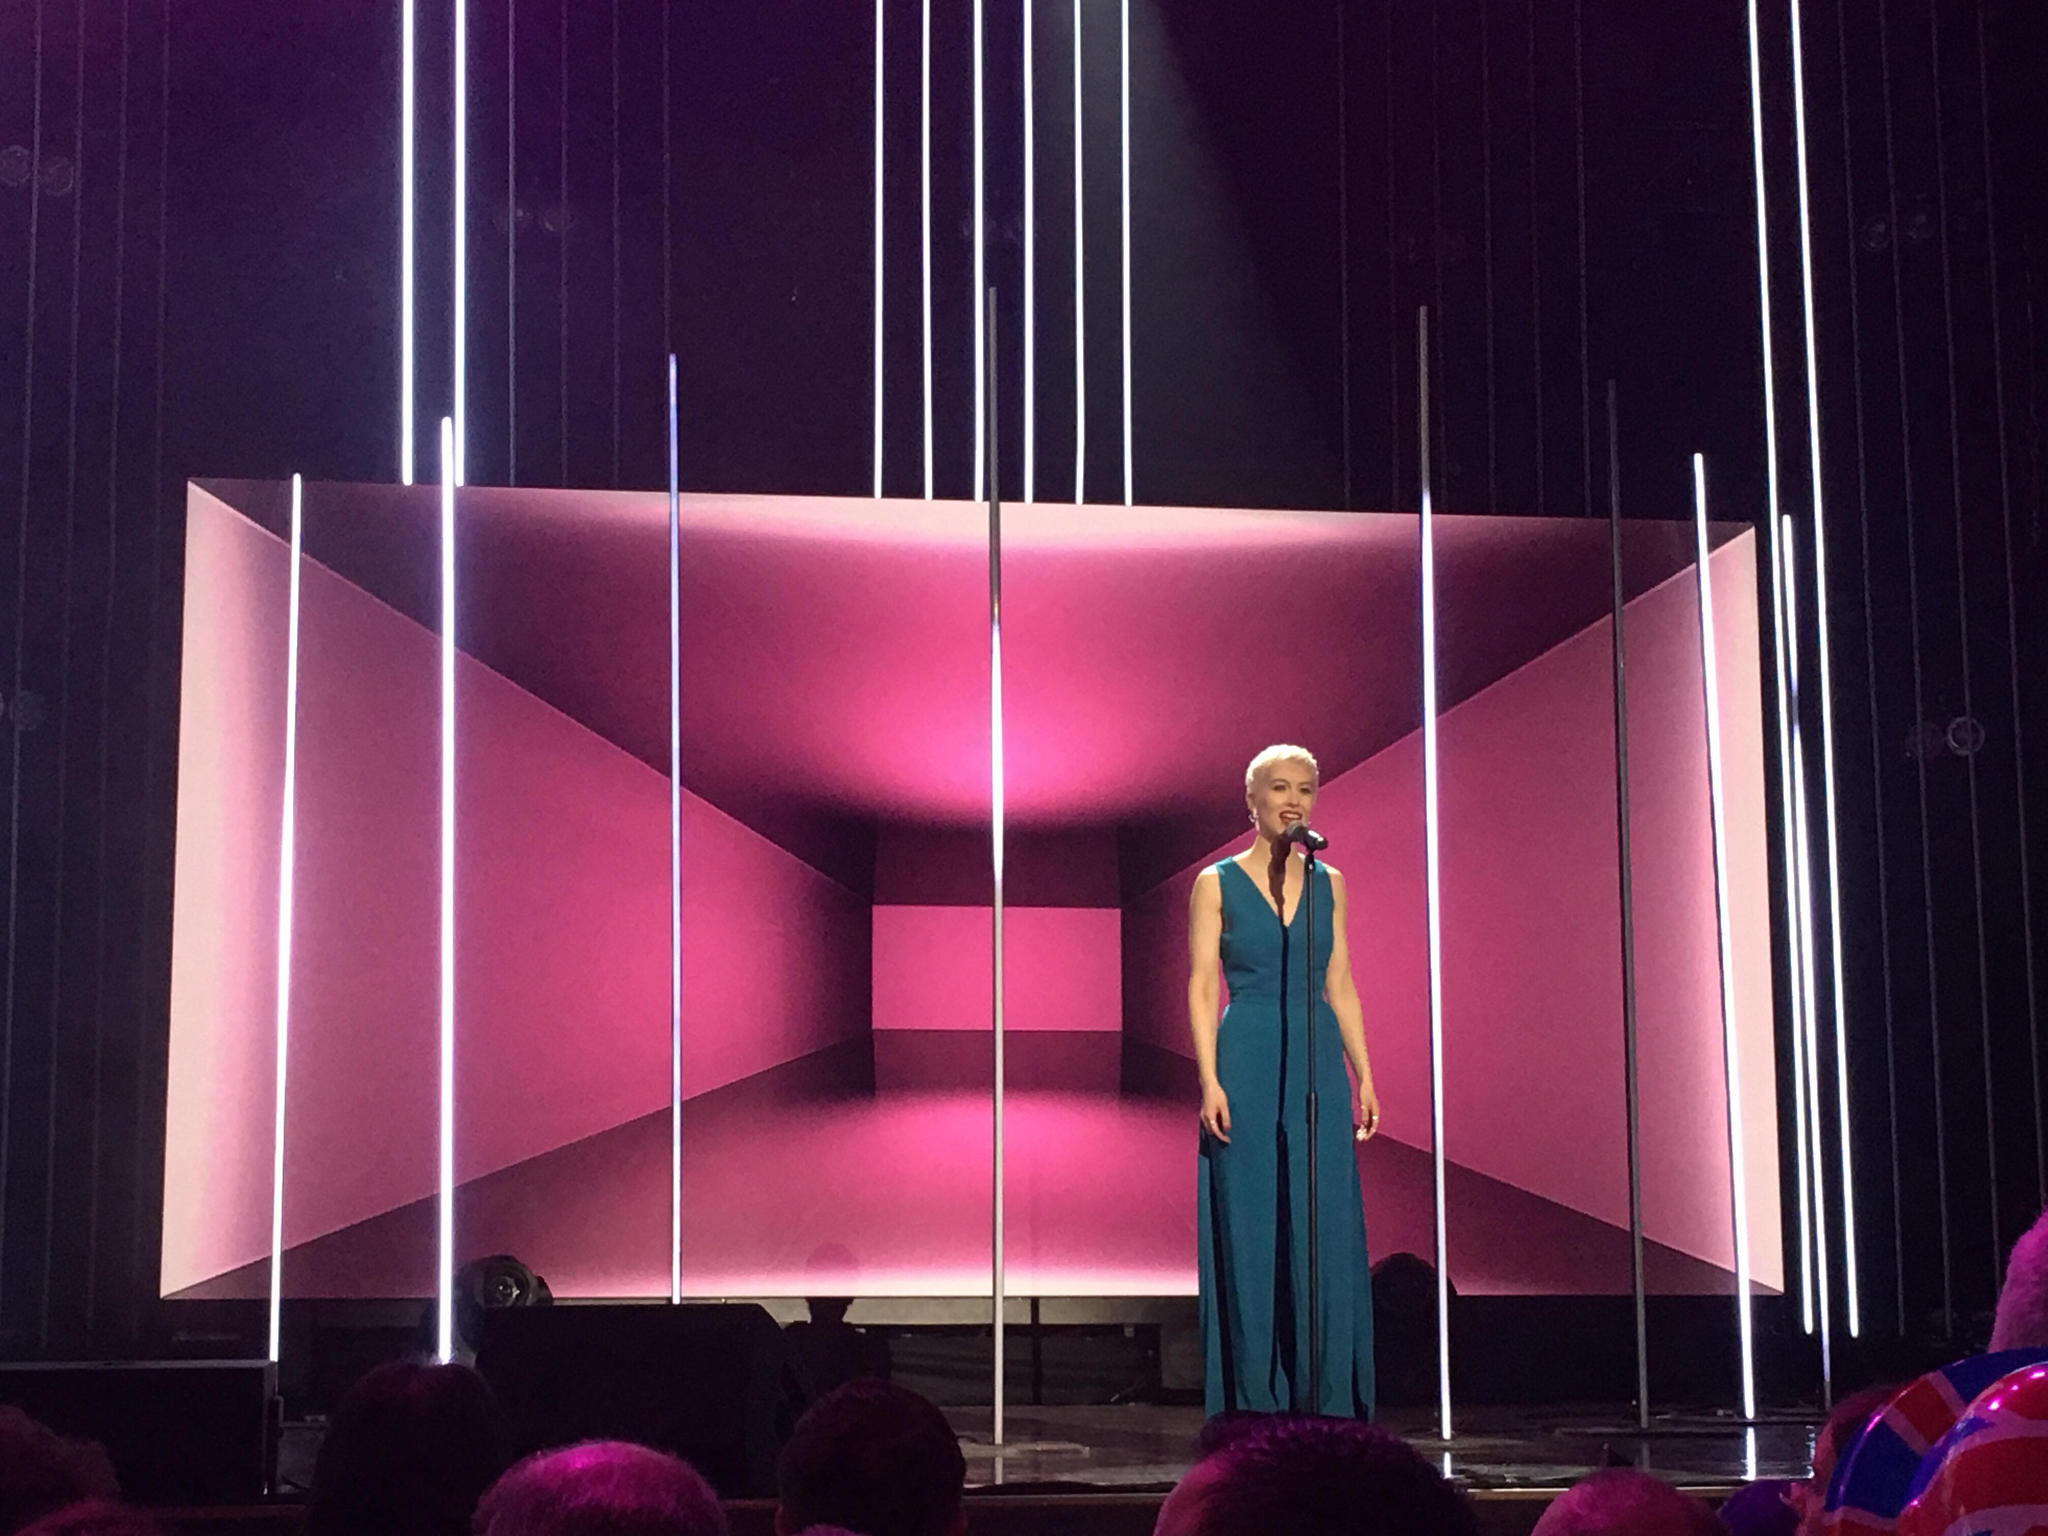How does the performer's attire complement the stage setup? The performer's elegant attire, with its deep blue tone, stands out against the vibrant backdrop without clashing, suggesting a thoughtful coordination. The simplicity of the dress provides a contrast to the complex stage design, allowing the performer to be the focal point while harmonizing with the stage's modern and sleek mood. 